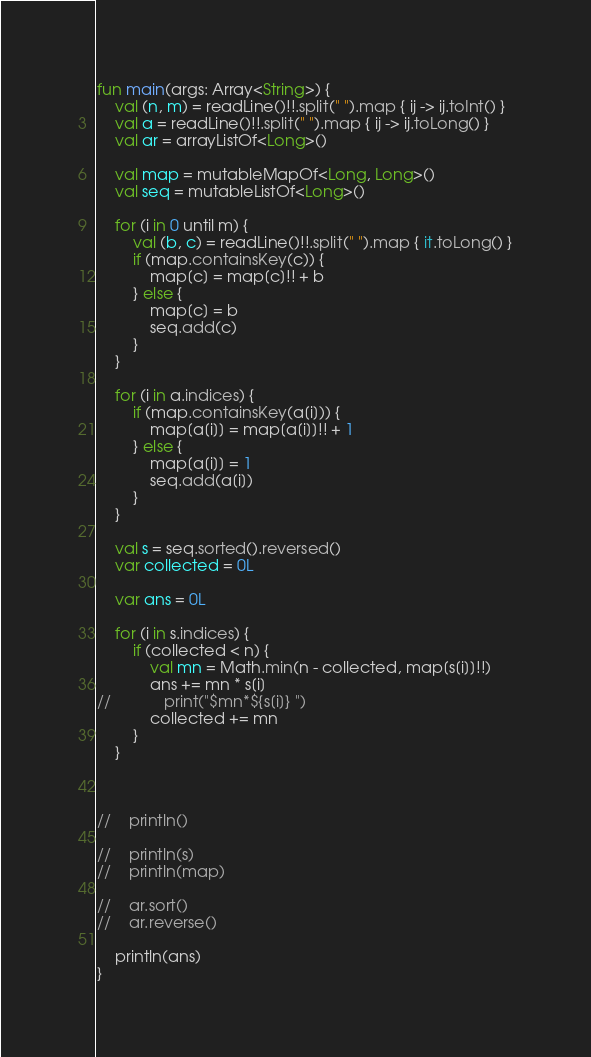Convert code to text. <code><loc_0><loc_0><loc_500><loc_500><_Kotlin_>fun main(args: Array<String>) {
    val (n, m) = readLine()!!.split(" ").map { ij -> ij.toInt() }
    val a = readLine()!!.split(" ").map { ij -> ij.toLong() }
    val ar = arrayListOf<Long>()
    
    val map = mutableMapOf<Long, Long>()
    val seq = mutableListOf<Long>()
    
    for (i in 0 until m) {
        val (b, c) = readLine()!!.split(" ").map { it.toLong() }
        if (map.containsKey(c)) {
            map[c] = map[c]!! + b
        } else {
            map[c] = b
            seq.add(c)
        }
    }
    
    for (i in a.indices) {
        if (map.containsKey(a[i])) {
            map[a[i]] = map[a[i]]!! + 1
        } else {
            map[a[i]] = 1
            seq.add(a[i])
        }
    }
    
    val s = seq.sorted().reversed()
    var collected = 0L
    
    var ans = 0L
    
    for (i in s.indices) {
        if (collected < n) {
            val mn = Math.min(n - collected, map[s[i]]!!)
            ans += mn * s[i]
//            print("$mn*${s[i]} ")
            collected += mn
        }
    }
    
    
    
//    println()
    
//    println(s)
//    println(map)

//    ar.sort()
//    ar.reverse()
    
    println(ans)
}
</code> 